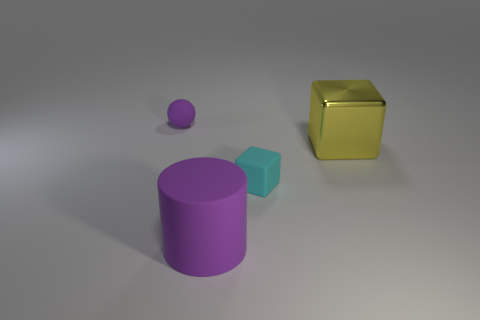What is the tiny object that is on the left side of the rubber object on the right side of the big purple cylinder made of?
Keep it short and to the point. Rubber. What is the size of the purple rubber sphere?
Your response must be concise. Small. The cylinder that is made of the same material as the tiny cyan thing is what size?
Keep it short and to the point. Large. Do the object to the right of the cyan cube and the purple matte cylinder have the same size?
Ensure brevity in your answer.  Yes. The small matte object that is in front of the purple rubber thing to the left of the large object to the left of the shiny cube is what shape?
Your answer should be compact. Cube. What number of things are either brown rubber objects or large metallic objects behind the small cyan thing?
Ensure brevity in your answer.  1. There is a purple matte cylinder to the right of the purple rubber ball; how big is it?
Offer a terse response. Large. There is a matte thing that is the same color as the big cylinder; what is its shape?
Keep it short and to the point. Sphere. Do the large yellow block and the block in front of the big yellow metallic block have the same material?
Your response must be concise. No. What number of large cylinders are on the right side of the tiny cube in front of the small thing that is behind the tiny rubber block?
Make the answer very short. 0. 